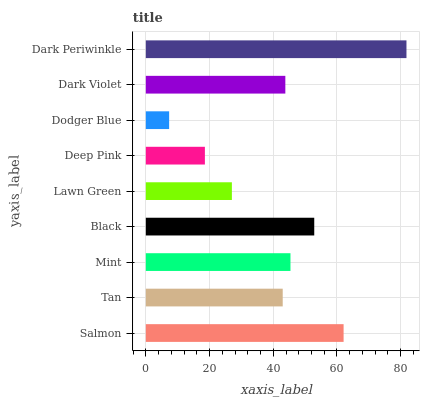Is Dodger Blue the minimum?
Answer yes or no. Yes. Is Dark Periwinkle the maximum?
Answer yes or no. Yes. Is Tan the minimum?
Answer yes or no. No. Is Tan the maximum?
Answer yes or no. No. Is Salmon greater than Tan?
Answer yes or no. Yes. Is Tan less than Salmon?
Answer yes or no. Yes. Is Tan greater than Salmon?
Answer yes or no. No. Is Salmon less than Tan?
Answer yes or no. No. Is Dark Violet the high median?
Answer yes or no. Yes. Is Dark Violet the low median?
Answer yes or no. Yes. Is Tan the high median?
Answer yes or no. No. Is Mint the low median?
Answer yes or no. No. 